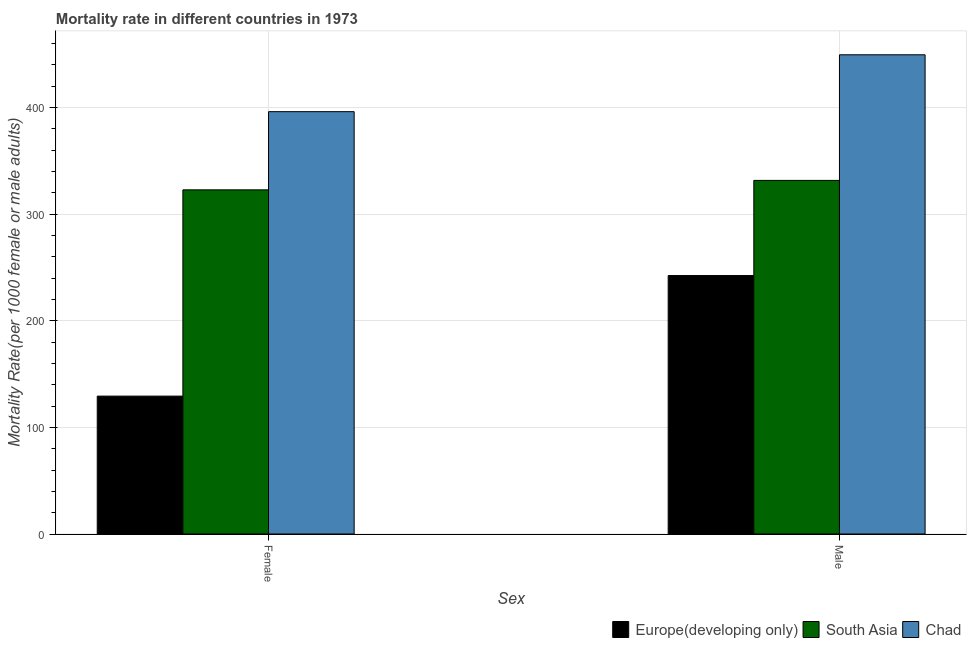How many different coloured bars are there?
Give a very brief answer. 3. Are the number of bars per tick equal to the number of legend labels?
Provide a short and direct response. Yes. Are the number of bars on each tick of the X-axis equal?
Provide a succinct answer. Yes. How many bars are there on the 2nd tick from the right?
Provide a succinct answer. 3. What is the label of the 2nd group of bars from the left?
Your answer should be very brief. Male. What is the female mortality rate in Chad?
Offer a very short reply. 396.07. Across all countries, what is the maximum female mortality rate?
Offer a very short reply. 396.07. Across all countries, what is the minimum female mortality rate?
Make the answer very short. 129.3. In which country was the male mortality rate maximum?
Offer a terse response. Chad. In which country was the male mortality rate minimum?
Your answer should be compact. Europe(developing only). What is the total female mortality rate in the graph?
Your answer should be very brief. 848.13. What is the difference between the female mortality rate in Europe(developing only) and that in Chad?
Make the answer very short. -266.76. What is the difference between the male mortality rate in Europe(developing only) and the female mortality rate in South Asia?
Offer a terse response. -80.38. What is the average female mortality rate per country?
Give a very brief answer. 282.71. What is the difference between the female mortality rate and male mortality rate in Europe(developing only)?
Offer a very short reply. -113.08. What is the ratio of the female mortality rate in Chad to that in Europe(developing only)?
Your answer should be very brief. 3.06. What does the 2nd bar from the left in Male represents?
Keep it short and to the point. South Asia. What does the 3rd bar from the right in Female represents?
Provide a short and direct response. Europe(developing only). How many bars are there?
Give a very brief answer. 6. What is the difference between two consecutive major ticks on the Y-axis?
Ensure brevity in your answer.  100. Does the graph contain any zero values?
Ensure brevity in your answer.  No. Does the graph contain grids?
Provide a short and direct response. Yes. How many legend labels are there?
Your response must be concise. 3. How are the legend labels stacked?
Offer a terse response. Horizontal. What is the title of the graph?
Ensure brevity in your answer.  Mortality rate in different countries in 1973. Does "Bermuda" appear as one of the legend labels in the graph?
Offer a very short reply. No. What is the label or title of the X-axis?
Provide a succinct answer. Sex. What is the label or title of the Y-axis?
Offer a very short reply. Mortality Rate(per 1000 female or male adults). What is the Mortality Rate(per 1000 female or male adults) in Europe(developing only) in Female?
Your response must be concise. 129.3. What is the Mortality Rate(per 1000 female or male adults) in South Asia in Female?
Keep it short and to the point. 322.76. What is the Mortality Rate(per 1000 female or male adults) of Chad in Female?
Give a very brief answer. 396.07. What is the Mortality Rate(per 1000 female or male adults) of Europe(developing only) in Male?
Offer a very short reply. 242.38. What is the Mortality Rate(per 1000 female or male adults) in South Asia in Male?
Your answer should be very brief. 331.61. What is the Mortality Rate(per 1000 female or male adults) of Chad in Male?
Give a very brief answer. 449.41. Across all Sex, what is the maximum Mortality Rate(per 1000 female or male adults) in Europe(developing only)?
Offer a very short reply. 242.38. Across all Sex, what is the maximum Mortality Rate(per 1000 female or male adults) in South Asia?
Your answer should be compact. 331.61. Across all Sex, what is the maximum Mortality Rate(per 1000 female or male adults) of Chad?
Your answer should be compact. 449.41. Across all Sex, what is the minimum Mortality Rate(per 1000 female or male adults) of Europe(developing only)?
Keep it short and to the point. 129.3. Across all Sex, what is the minimum Mortality Rate(per 1000 female or male adults) of South Asia?
Keep it short and to the point. 322.76. Across all Sex, what is the minimum Mortality Rate(per 1000 female or male adults) of Chad?
Ensure brevity in your answer.  396.07. What is the total Mortality Rate(per 1000 female or male adults) in Europe(developing only) in the graph?
Provide a succinct answer. 371.68. What is the total Mortality Rate(per 1000 female or male adults) in South Asia in the graph?
Ensure brevity in your answer.  654.37. What is the total Mortality Rate(per 1000 female or male adults) in Chad in the graph?
Offer a terse response. 845.48. What is the difference between the Mortality Rate(per 1000 female or male adults) of Europe(developing only) in Female and that in Male?
Your response must be concise. -113.08. What is the difference between the Mortality Rate(per 1000 female or male adults) in South Asia in Female and that in Male?
Offer a terse response. -8.85. What is the difference between the Mortality Rate(per 1000 female or male adults) of Chad in Female and that in Male?
Your answer should be very brief. -53.34. What is the difference between the Mortality Rate(per 1000 female or male adults) in Europe(developing only) in Female and the Mortality Rate(per 1000 female or male adults) in South Asia in Male?
Offer a very short reply. -202.31. What is the difference between the Mortality Rate(per 1000 female or male adults) in Europe(developing only) in Female and the Mortality Rate(per 1000 female or male adults) in Chad in Male?
Your answer should be compact. -320.11. What is the difference between the Mortality Rate(per 1000 female or male adults) in South Asia in Female and the Mortality Rate(per 1000 female or male adults) in Chad in Male?
Give a very brief answer. -126.65. What is the average Mortality Rate(per 1000 female or male adults) of Europe(developing only) per Sex?
Offer a very short reply. 185.84. What is the average Mortality Rate(per 1000 female or male adults) in South Asia per Sex?
Keep it short and to the point. 327.18. What is the average Mortality Rate(per 1000 female or male adults) of Chad per Sex?
Provide a short and direct response. 422.74. What is the difference between the Mortality Rate(per 1000 female or male adults) in Europe(developing only) and Mortality Rate(per 1000 female or male adults) in South Asia in Female?
Provide a succinct answer. -193.46. What is the difference between the Mortality Rate(per 1000 female or male adults) of Europe(developing only) and Mortality Rate(per 1000 female or male adults) of Chad in Female?
Your answer should be compact. -266.76. What is the difference between the Mortality Rate(per 1000 female or male adults) in South Asia and Mortality Rate(per 1000 female or male adults) in Chad in Female?
Provide a short and direct response. -73.31. What is the difference between the Mortality Rate(per 1000 female or male adults) in Europe(developing only) and Mortality Rate(per 1000 female or male adults) in South Asia in Male?
Keep it short and to the point. -89.23. What is the difference between the Mortality Rate(per 1000 female or male adults) of Europe(developing only) and Mortality Rate(per 1000 female or male adults) of Chad in Male?
Make the answer very short. -207.03. What is the difference between the Mortality Rate(per 1000 female or male adults) of South Asia and Mortality Rate(per 1000 female or male adults) of Chad in Male?
Ensure brevity in your answer.  -117.8. What is the ratio of the Mortality Rate(per 1000 female or male adults) of Europe(developing only) in Female to that in Male?
Provide a short and direct response. 0.53. What is the ratio of the Mortality Rate(per 1000 female or male adults) of South Asia in Female to that in Male?
Your answer should be very brief. 0.97. What is the ratio of the Mortality Rate(per 1000 female or male adults) of Chad in Female to that in Male?
Your answer should be compact. 0.88. What is the difference between the highest and the second highest Mortality Rate(per 1000 female or male adults) of Europe(developing only)?
Provide a short and direct response. 113.08. What is the difference between the highest and the second highest Mortality Rate(per 1000 female or male adults) in South Asia?
Give a very brief answer. 8.85. What is the difference between the highest and the second highest Mortality Rate(per 1000 female or male adults) of Chad?
Ensure brevity in your answer.  53.34. What is the difference between the highest and the lowest Mortality Rate(per 1000 female or male adults) in Europe(developing only)?
Keep it short and to the point. 113.08. What is the difference between the highest and the lowest Mortality Rate(per 1000 female or male adults) of South Asia?
Your answer should be very brief. 8.85. What is the difference between the highest and the lowest Mortality Rate(per 1000 female or male adults) in Chad?
Your answer should be very brief. 53.34. 